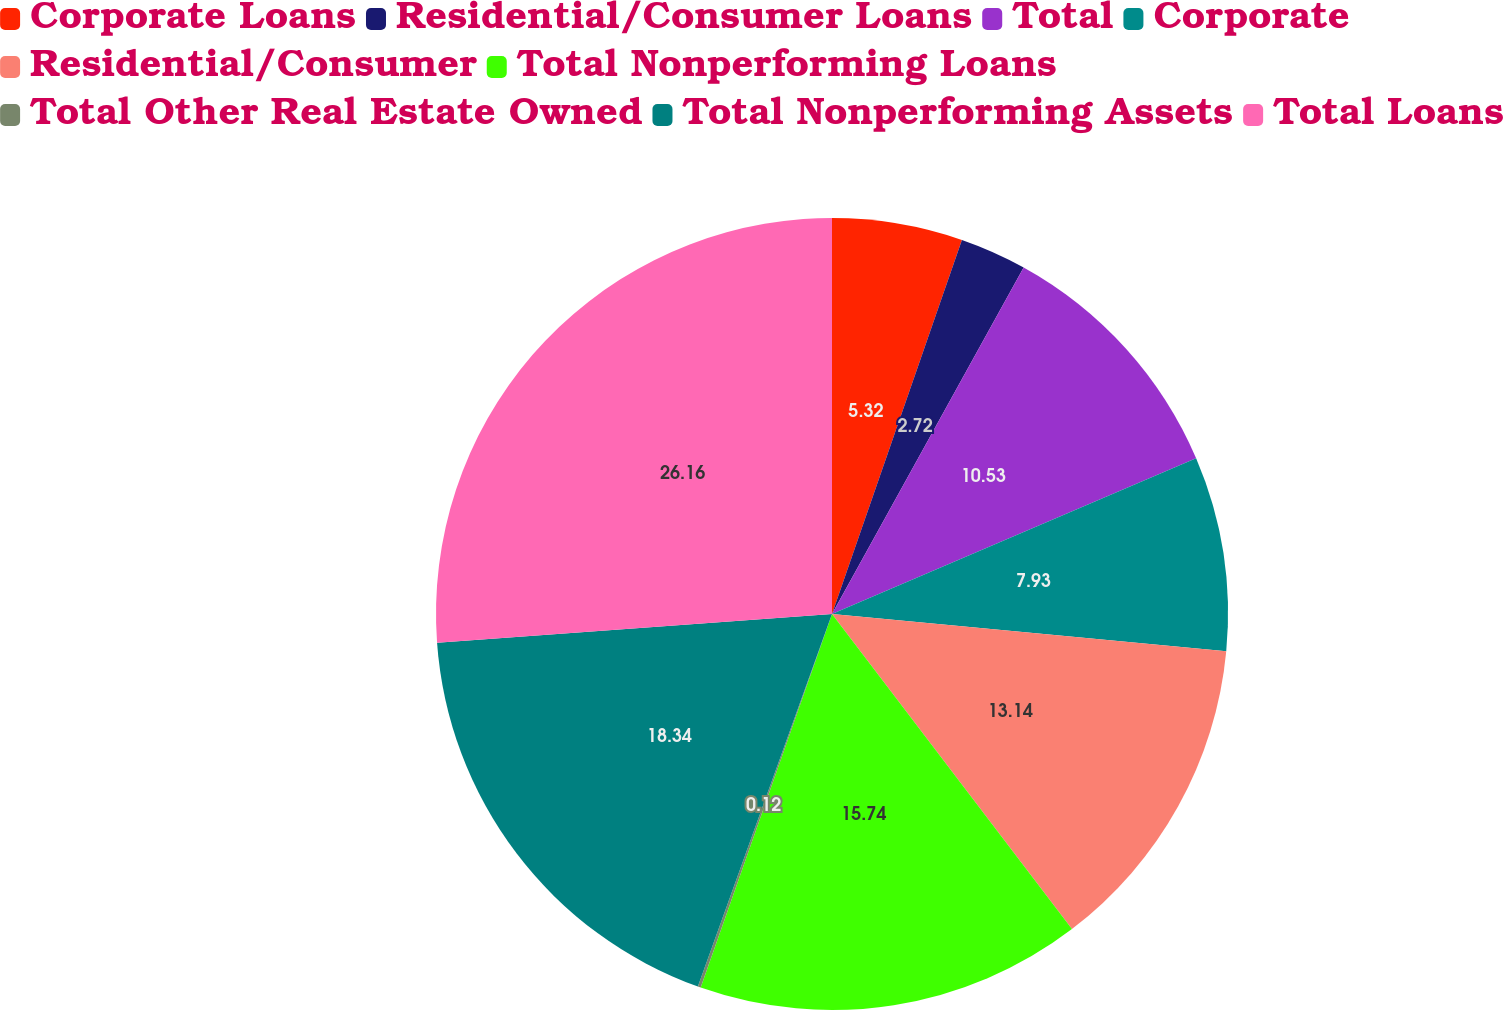Convert chart. <chart><loc_0><loc_0><loc_500><loc_500><pie_chart><fcel>Corporate Loans<fcel>Residential/Consumer Loans<fcel>Total<fcel>Corporate<fcel>Residential/Consumer<fcel>Total Nonperforming Loans<fcel>Total Other Real Estate Owned<fcel>Total Nonperforming Assets<fcel>Total Loans<nl><fcel>5.32%<fcel>2.72%<fcel>10.53%<fcel>7.93%<fcel>13.14%<fcel>15.74%<fcel>0.12%<fcel>18.34%<fcel>26.16%<nl></chart> 